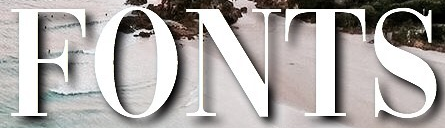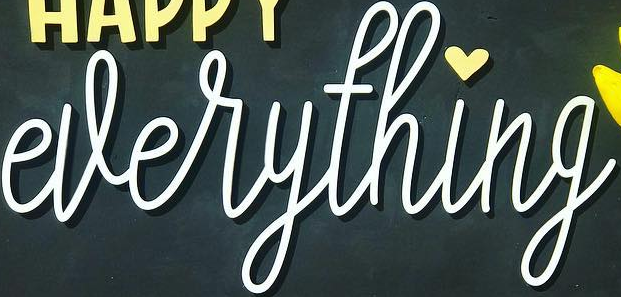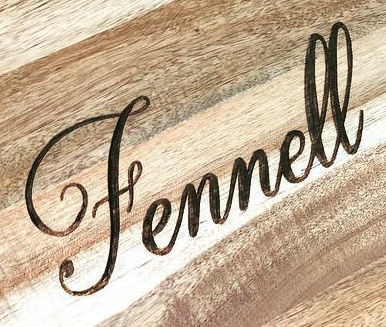Transcribe the words shown in these images in order, separated by a semicolon. FONTS; everything; Fennell 